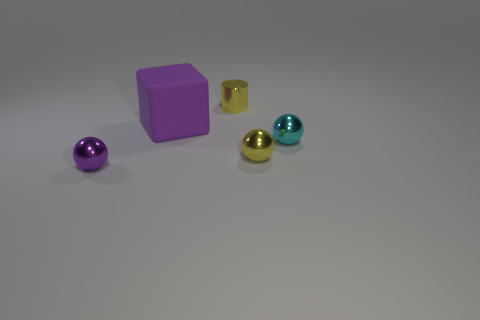Subtract all purple balls. How many balls are left? 2 Subtract all small yellow metallic spheres. How many spheres are left? 2 Add 1 blocks. How many objects exist? 6 Subtract 2 balls. How many balls are left? 1 Subtract all cylinders. How many objects are left? 4 Subtract all tiny purple metallic things. Subtract all balls. How many objects are left? 1 Add 4 tiny cyan metallic objects. How many tiny cyan metallic objects are left? 5 Add 1 large brown matte balls. How many large brown matte balls exist? 1 Subtract 0 green balls. How many objects are left? 5 Subtract all cyan cylinders. Subtract all gray blocks. How many cylinders are left? 1 